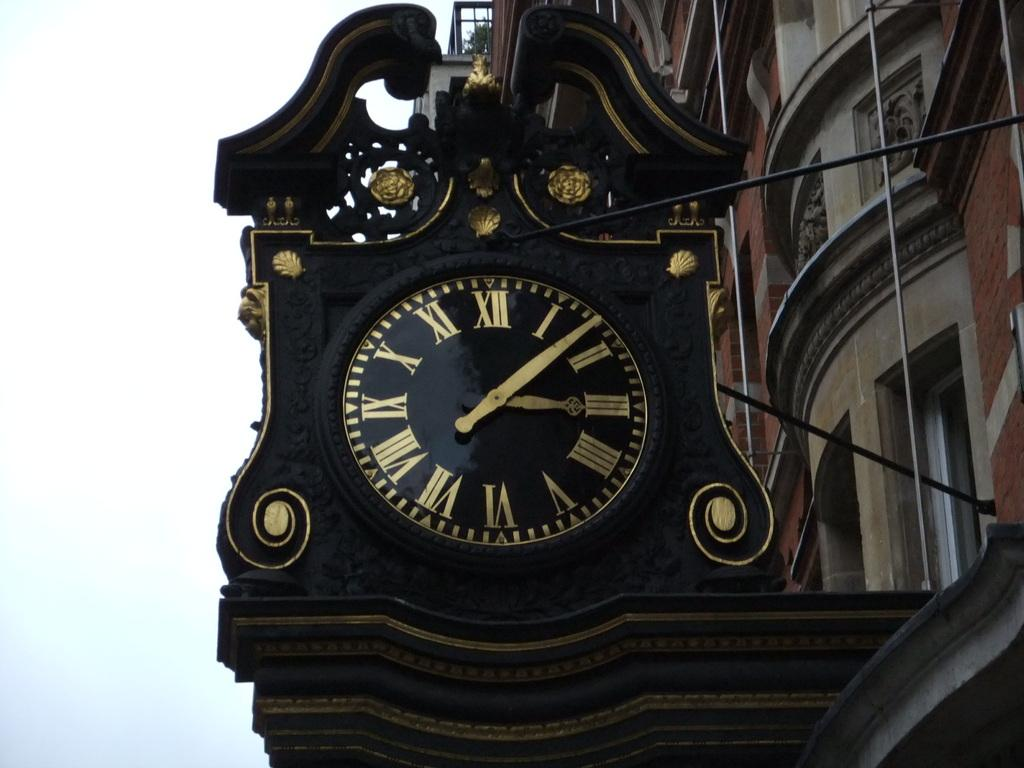What is the main subject of the image? The main subject of the image is a building. What feature can be seen on the building? There is a clock on the building. What type of vegetation is present on the building? There is a plant at the top of the building. What is visible at the top of the image? The sky is visible at the top of the image. What type of trouble are the pigs causing on the building in the image? There are no pigs present in the image, so it is not possible to determine if they are causing any trouble. 